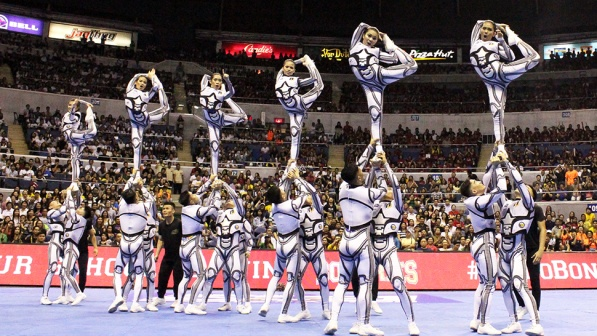Imagine the cheerleaders are performing this stunt on a different planet. Describe the setting and the audience. Imagine the cheerleaders performing on a distant alien planet under a sky filled with twinkling stars and two glowing moons. The ground they stand on is made of sparkling, iridescent minerals, casting a magical glow around them. The audience is a diverse gathering of curious alien species, with various shapes, colors, and sizes. Some have multiple eyes, others have tentacles, and they are all utterly captivated by the performance. Holographic signs float in the air, displaying cheers in different alien languages. The atmosphere is electrifying, a blend of interstellar wonder and universal admiration for the cheerleaders' incredible skills. 